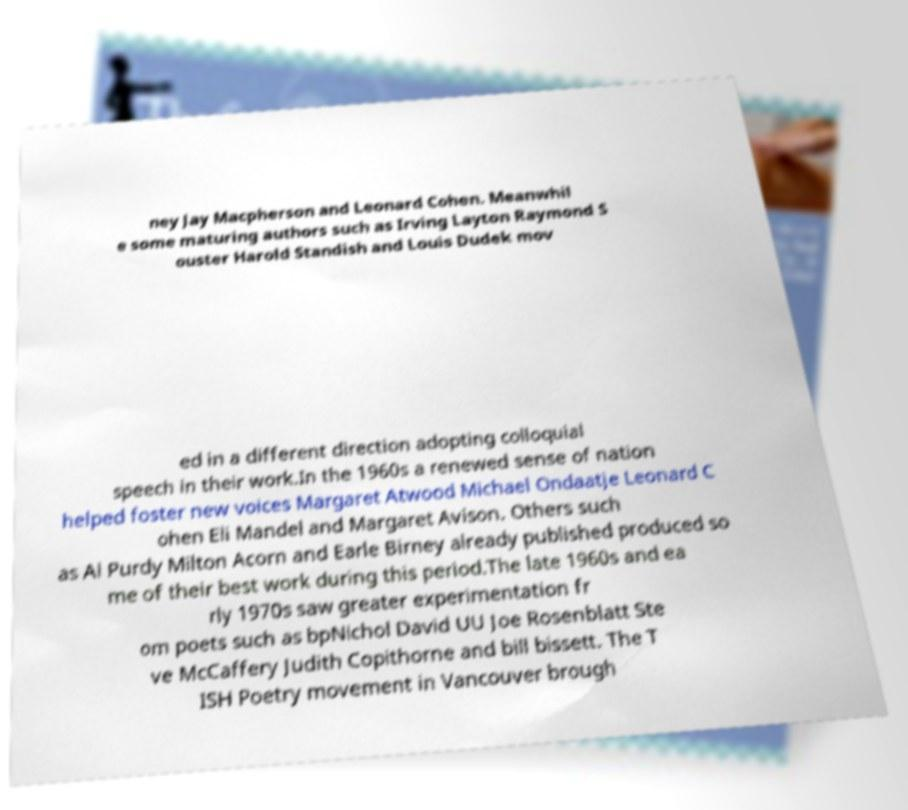I need the written content from this picture converted into text. Can you do that? ney Jay Macpherson and Leonard Cohen. Meanwhil e some maturing authors such as Irving Layton Raymond S ouster Harold Standish and Louis Dudek mov ed in a different direction adopting colloquial speech in their work.In the 1960s a renewed sense of nation helped foster new voices Margaret Atwood Michael Ondaatje Leonard C ohen Eli Mandel and Margaret Avison. Others such as Al Purdy Milton Acorn and Earle Birney already published produced so me of their best work during this period.The late 1960s and ea rly 1970s saw greater experimentation fr om poets such as bpNichol David UU Joe Rosenblatt Ste ve McCaffery Judith Copithorne and bill bissett. The T ISH Poetry movement in Vancouver brough 